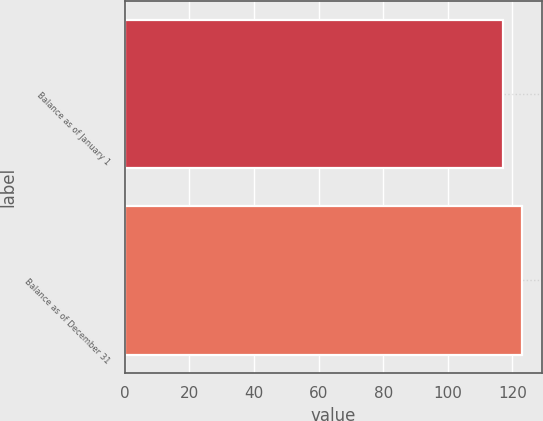<chart> <loc_0><loc_0><loc_500><loc_500><bar_chart><fcel>Balance as of January 1<fcel>Balance as of December 31<nl><fcel>117<fcel>123<nl></chart> 